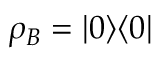Convert formula to latex. <formula><loc_0><loc_0><loc_500><loc_500>\rho _ { B } = | 0 \rangle \langle 0 |</formula> 